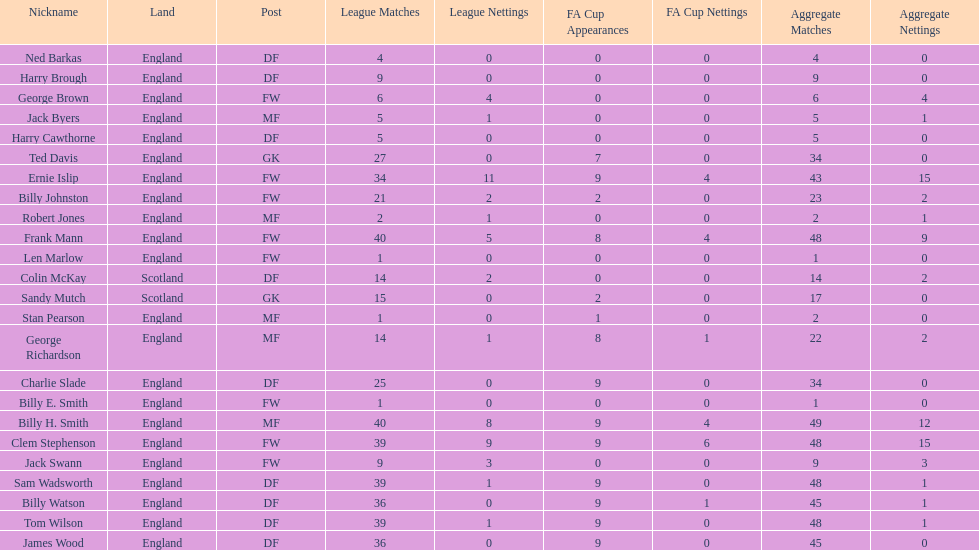What is the last name listed on this chart? James Wood. 